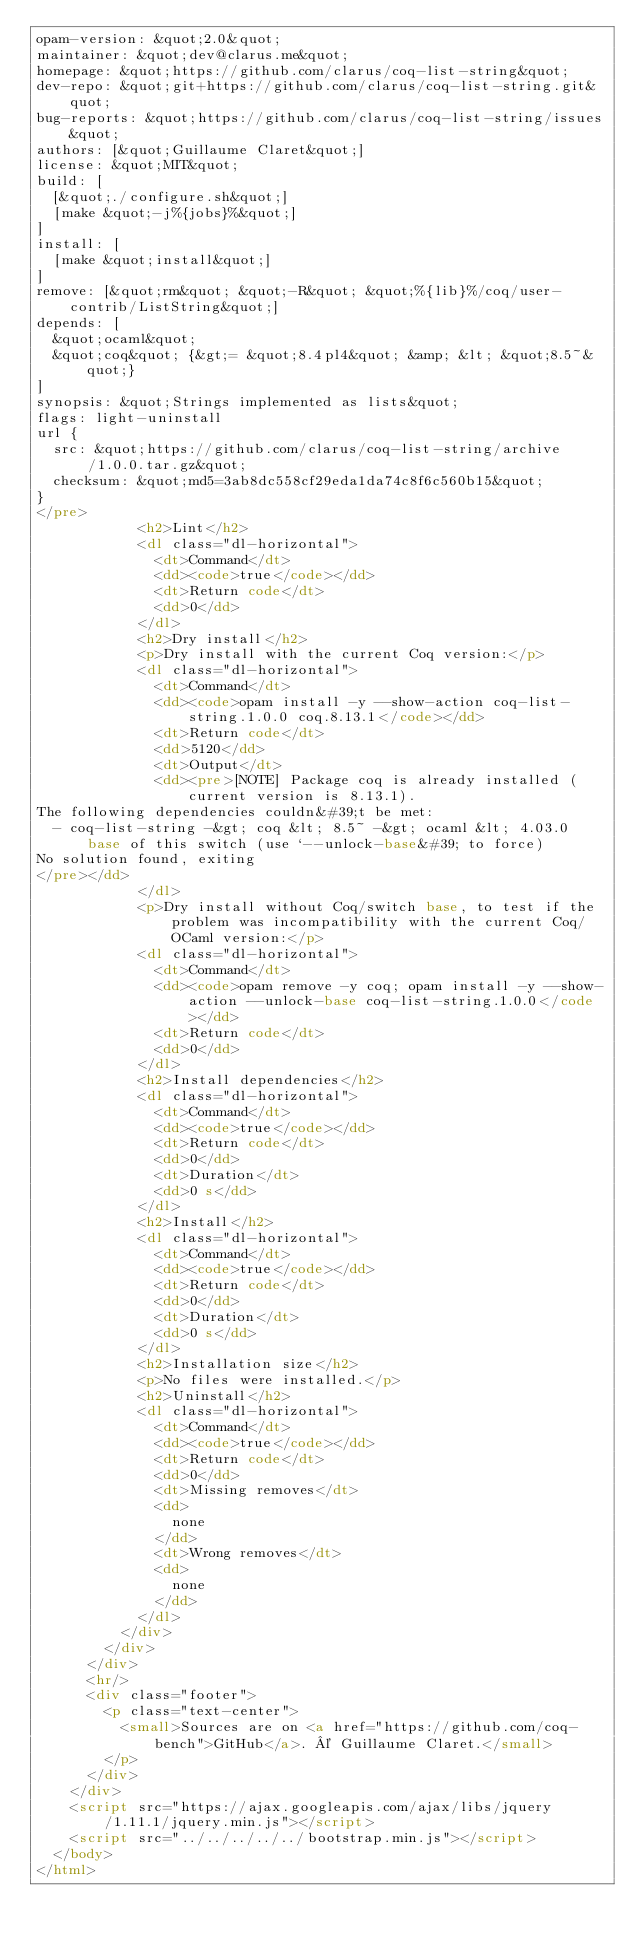Convert code to text. <code><loc_0><loc_0><loc_500><loc_500><_HTML_>opam-version: &quot;2.0&quot;
maintainer: &quot;dev@clarus.me&quot;
homepage: &quot;https://github.com/clarus/coq-list-string&quot;
dev-repo: &quot;git+https://github.com/clarus/coq-list-string.git&quot;
bug-reports: &quot;https://github.com/clarus/coq-list-string/issues&quot;
authors: [&quot;Guillaume Claret&quot;]
license: &quot;MIT&quot;
build: [
  [&quot;./configure.sh&quot;]
  [make &quot;-j%{jobs}%&quot;]
]
install: [
  [make &quot;install&quot;]
]
remove: [&quot;rm&quot; &quot;-R&quot; &quot;%{lib}%/coq/user-contrib/ListString&quot;]
depends: [
  &quot;ocaml&quot;
  &quot;coq&quot; {&gt;= &quot;8.4pl4&quot; &amp; &lt; &quot;8.5~&quot;}
]
synopsis: &quot;Strings implemented as lists&quot;
flags: light-uninstall
url {
  src: &quot;https://github.com/clarus/coq-list-string/archive/1.0.0.tar.gz&quot;
  checksum: &quot;md5=3ab8dc558cf29eda1da74c8f6c560b15&quot;
}
</pre>
            <h2>Lint</h2>
            <dl class="dl-horizontal">
              <dt>Command</dt>
              <dd><code>true</code></dd>
              <dt>Return code</dt>
              <dd>0</dd>
            </dl>
            <h2>Dry install</h2>
            <p>Dry install with the current Coq version:</p>
            <dl class="dl-horizontal">
              <dt>Command</dt>
              <dd><code>opam install -y --show-action coq-list-string.1.0.0 coq.8.13.1</code></dd>
              <dt>Return code</dt>
              <dd>5120</dd>
              <dt>Output</dt>
              <dd><pre>[NOTE] Package coq is already installed (current version is 8.13.1).
The following dependencies couldn&#39;t be met:
  - coq-list-string -&gt; coq &lt; 8.5~ -&gt; ocaml &lt; 4.03.0
      base of this switch (use `--unlock-base&#39; to force)
No solution found, exiting
</pre></dd>
            </dl>
            <p>Dry install without Coq/switch base, to test if the problem was incompatibility with the current Coq/OCaml version:</p>
            <dl class="dl-horizontal">
              <dt>Command</dt>
              <dd><code>opam remove -y coq; opam install -y --show-action --unlock-base coq-list-string.1.0.0</code></dd>
              <dt>Return code</dt>
              <dd>0</dd>
            </dl>
            <h2>Install dependencies</h2>
            <dl class="dl-horizontal">
              <dt>Command</dt>
              <dd><code>true</code></dd>
              <dt>Return code</dt>
              <dd>0</dd>
              <dt>Duration</dt>
              <dd>0 s</dd>
            </dl>
            <h2>Install</h2>
            <dl class="dl-horizontal">
              <dt>Command</dt>
              <dd><code>true</code></dd>
              <dt>Return code</dt>
              <dd>0</dd>
              <dt>Duration</dt>
              <dd>0 s</dd>
            </dl>
            <h2>Installation size</h2>
            <p>No files were installed.</p>
            <h2>Uninstall</h2>
            <dl class="dl-horizontal">
              <dt>Command</dt>
              <dd><code>true</code></dd>
              <dt>Return code</dt>
              <dd>0</dd>
              <dt>Missing removes</dt>
              <dd>
                none
              </dd>
              <dt>Wrong removes</dt>
              <dd>
                none
              </dd>
            </dl>
          </div>
        </div>
      </div>
      <hr/>
      <div class="footer">
        <p class="text-center">
          <small>Sources are on <a href="https://github.com/coq-bench">GitHub</a>. © Guillaume Claret.</small>
        </p>
      </div>
    </div>
    <script src="https://ajax.googleapis.com/ajax/libs/jquery/1.11.1/jquery.min.js"></script>
    <script src="../../../../../bootstrap.min.js"></script>
  </body>
</html>
</code> 